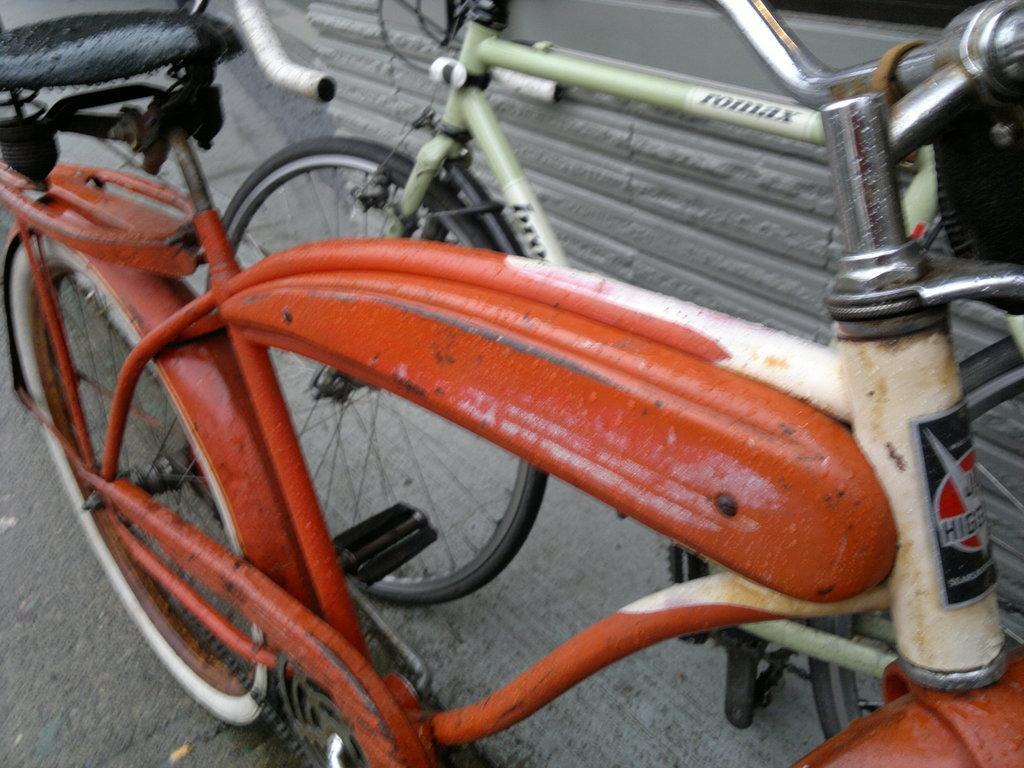Please provide a concise description of this image. In this image we can see two bicycles in which one is in orange color and the other one is green. 